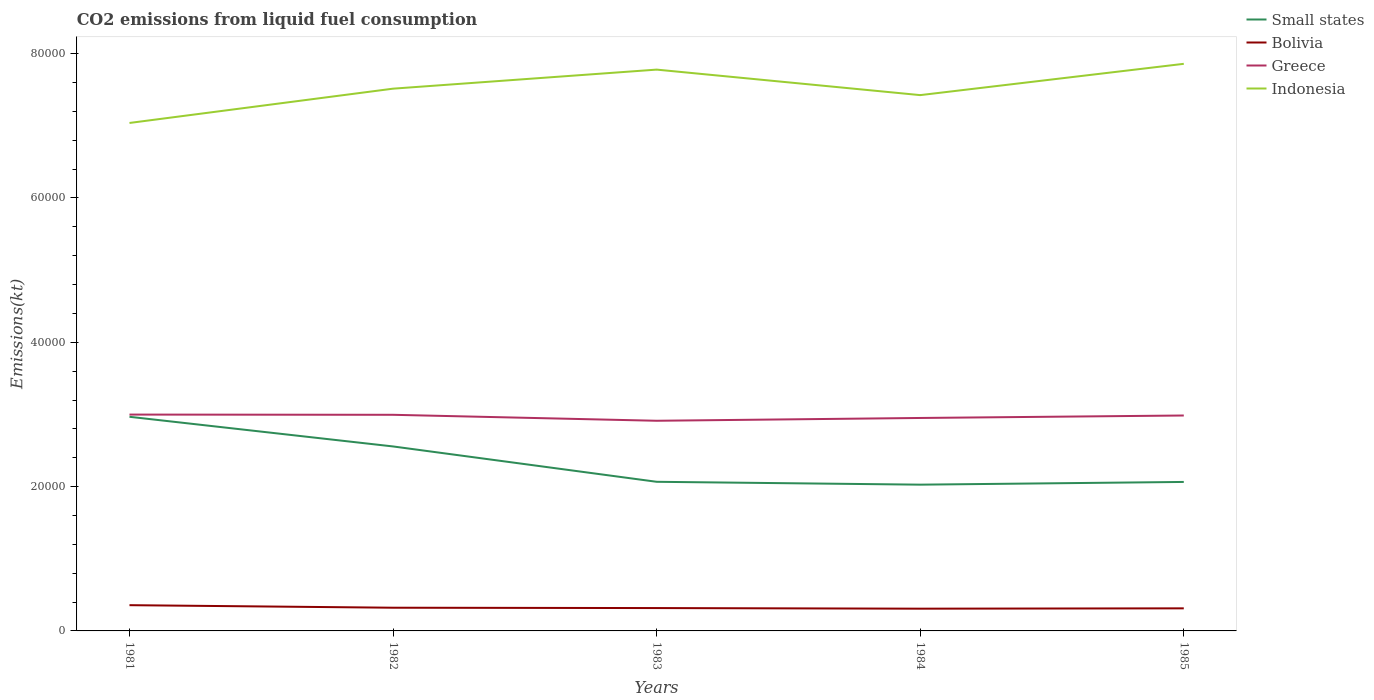Does the line corresponding to Greece intersect with the line corresponding to Bolivia?
Give a very brief answer. No. Across all years, what is the maximum amount of CO2 emitted in Indonesia?
Make the answer very short. 7.04e+04. What is the total amount of CO2 emitted in Greece in the graph?
Provide a succinct answer. 29.34. What is the difference between the highest and the second highest amount of CO2 emitted in Greece?
Offer a very short reply. 858.08. What is the difference between the highest and the lowest amount of CO2 emitted in Bolivia?
Offer a terse response. 1. How many lines are there?
Offer a very short reply. 4. How many years are there in the graph?
Ensure brevity in your answer.  5. What is the title of the graph?
Offer a terse response. CO2 emissions from liquid fuel consumption. Does "Liberia" appear as one of the legend labels in the graph?
Ensure brevity in your answer.  No. What is the label or title of the Y-axis?
Make the answer very short. Emissions(kt). What is the Emissions(kt) in Small states in 1981?
Provide a succinct answer. 2.97e+04. What is the Emissions(kt) of Bolivia in 1981?
Provide a succinct answer. 3567.99. What is the Emissions(kt) in Greece in 1981?
Your response must be concise. 3.00e+04. What is the Emissions(kt) of Indonesia in 1981?
Your response must be concise. 7.04e+04. What is the Emissions(kt) of Small states in 1982?
Your response must be concise. 2.56e+04. What is the Emissions(kt) of Bolivia in 1982?
Make the answer very short. 3215.96. What is the Emissions(kt) in Greece in 1982?
Your answer should be compact. 3.00e+04. What is the Emissions(kt) of Indonesia in 1982?
Ensure brevity in your answer.  7.51e+04. What is the Emissions(kt) of Small states in 1983?
Your answer should be very brief. 2.07e+04. What is the Emissions(kt) of Bolivia in 1983?
Make the answer very short. 3168.29. What is the Emissions(kt) in Greece in 1983?
Offer a terse response. 2.91e+04. What is the Emissions(kt) in Indonesia in 1983?
Ensure brevity in your answer.  7.78e+04. What is the Emissions(kt) of Small states in 1984?
Ensure brevity in your answer.  2.03e+04. What is the Emissions(kt) in Bolivia in 1984?
Offer a very short reply. 3083.95. What is the Emissions(kt) in Greece in 1984?
Ensure brevity in your answer.  2.95e+04. What is the Emissions(kt) in Indonesia in 1984?
Keep it short and to the point. 7.43e+04. What is the Emissions(kt) in Small states in 1985?
Your answer should be very brief. 2.06e+04. What is the Emissions(kt) of Bolivia in 1985?
Your answer should be very brief. 3127.95. What is the Emissions(kt) of Greece in 1985?
Your response must be concise. 2.99e+04. What is the Emissions(kt) of Indonesia in 1985?
Your answer should be very brief. 7.86e+04. Across all years, what is the maximum Emissions(kt) in Small states?
Make the answer very short. 2.97e+04. Across all years, what is the maximum Emissions(kt) in Bolivia?
Ensure brevity in your answer.  3567.99. Across all years, what is the maximum Emissions(kt) in Greece?
Offer a terse response. 3.00e+04. Across all years, what is the maximum Emissions(kt) in Indonesia?
Make the answer very short. 7.86e+04. Across all years, what is the minimum Emissions(kt) in Small states?
Keep it short and to the point. 2.03e+04. Across all years, what is the minimum Emissions(kt) of Bolivia?
Ensure brevity in your answer.  3083.95. Across all years, what is the minimum Emissions(kt) of Greece?
Provide a succinct answer. 2.91e+04. Across all years, what is the minimum Emissions(kt) in Indonesia?
Keep it short and to the point. 7.04e+04. What is the total Emissions(kt) of Small states in the graph?
Provide a short and direct response. 1.17e+05. What is the total Emissions(kt) in Bolivia in the graph?
Offer a very short reply. 1.62e+04. What is the total Emissions(kt) of Greece in the graph?
Offer a very short reply. 1.48e+05. What is the total Emissions(kt) of Indonesia in the graph?
Offer a very short reply. 3.76e+05. What is the difference between the Emissions(kt) in Small states in 1981 and that in 1982?
Provide a short and direct response. 4108.46. What is the difference between the Emissions(kt) in Bolivia in 1981 and that in 1982?
Ensure brevity in your answer.  352.03. What is the difference between the Emissions(kt) of Greece in 1981 and that in 1982?
Provide a short and direct response. 29.34. What is the difference between the Emissions(kt) of Indonesia in 1981 and that in 1982?
Your response must be concise. -4752.43. What is the difference between the Emissions(kt) in Small states in 1981 and that in 1983?
Provide a succinct answer. 9007.46. What is the difference between the Emissions(kt) of Bolivia in 1981 and that in 1983?
Offer a very short reply. 399.7. What is the difference between the Emissions(kt) of Greece in 1981 and that in 1983?
Your answer should be very brief. 858.08. What is the difference between the Emissions(kt) in Indonesia in 1981 and that in 1983?
Offer a very short reply. -7392.67. What is the difference between the Emissions(kt) of Small states in 1981 and that in 1984?
Provide a succinct answer. 9404.67. What is the difference between the Emissions(kt) of Bolivia in 1981 and that in 1984?
Make the answer very short. 484.04. What is the difference between the Emissions(kt) in Greece in 1981 and that in 1984?
Your answer should be compact. 469.38. What is the difference between the Emissions(kt) in Indonesia in 1981 and that in 1984?
Ensure brevity in your answer.  -3857.68. What is the difference between the Emissions(kt) of Small states in 1981 and that in 1985?
Make the answer very short. 9026.93. What is the difference between the Emissions(kt) in Bolivia in 1981 and that in 1985?
Your answer should be very brief. 440.04. What is the difference between the Emissions(kt) of Greece in 1981 and that in 1985?
Offer a very short reply. 128.34. What is the difference between the Emissions(kt) in Indonesia in 1981 and that in 1985?
Keep it short and to the point. -8195.75. What is the difference between the Emissions(kt) of Small states in 1982 and that in 1983?
Your answer should be compact. 4899. What is the difference between the Emissions(kt) in Bolivia in 1982 and that in 1983?
Offer a very short reply. 47.67. What is the difference between the Emissions(kt) of Greece in 1982 and that in 1983?
Keep it short and to the point. 828.74. What is the difference between the Emissions(kt) of Indonesia in 1982 and that in 1983?
Offer a terse response. -2640.24. What is the difference between the Emissions(kt) in Small states in 1982 and that in 1984?
Your response must be concise. 5296.21. What is the difference between the Emissions(kt) of Bolivia in 1982 and that in 1984?
Your answer should be very brief. 132.01. What is the difference between the Emissions(kt) of Greece in 1982 and that in 1984?
Give a very brief answer. 440.04. What is the difference between the Emissions(kt) in Indonesia in 1982 and that in 1984?
Ensure brevity in your answer.  894.75. What is the difference between the Emissions(kt) in Small states in 1982 and that in 1985?
Make the answer very short. 4918.47. What is the difference between the Emissions(kt) of Bolivia in 1982 and that in 1985?
Your answer should be compact. 88.01. What is the difference between the Emissions(kt) in Greece in 1982 and that in 1985?
Give a very brief answer. 99.01. What is the difference between the Emissions(kt) of Indonesia in 1982 and that in 1985?
Your response must be concise. -3443.31. What is the difference between the Emissions(kt) in Small states in 1983 and that in 1984?
Offer a very short reply. 397.22. What is the difference between the Emissions(kt) in Bolivia in 1983 and that in 1984?
Give a very brief answer. 84.34. What is the difference between the Emissions(kt) of Greece in 1983 and that in 1984?
Make the answer very short. -388.7. What is the difference between the Emissions(kt) of Indonesia in 1983 and that in 1984?
Your answer should be compact. 3534.99. What is the difference between the Emissions(kt) in Small states in 1983 and that in 1985?
Offer a terse response. 19.47. What is the difference between the Emissions(kt) in Bolivia in 1983 and that in 1985?
Keep it short and to the point. 40.34. What is the difference between the Emissions(kt) of Greece in 1983 and that in 1985?
Provide a succinct answer. -729.73. What is the difference between the Emissions(kt) in Indonesia in 1983 and that in 1985?
Provide a short and direct response. -803.07. What is the difference between the Emissions(kt) in Small states in 1984 and that in 1985?
Your answer should be very brief. -377.74. What is the difference between the Emissions(kt) in Bolivia in 1984 and that in 1985?
Your response must be concise. -44. What is the difference between the Emissions(kt) in Greece in 1984 and that in 1985?
Offer a very short reply. -341.03. What is the difference between the Emissions(kt) in Indonesia in 1984 and that in 1985?
Your answer should be compact. -4338.06. What is the difference between the Emissions(kt) in Small states in 1981 and the Emissions(kt) in Bolivia in 1982?
Offer a very short reply. 2.65e+04. What is the difference between the Emissions(kt) of Small states in 1981 and the Emissions(kt) of Greece in 1982?
Make the answer very short. -277.69. What is the difference between the Emissions(kt) in Small states in 1981 and the Emissions(kt) in Indonesia in 1982?
Give a very brief answer. -4.55e+04. What is the difference between the Emissions(kt) in Bolivia in 1981 and the Emissions(kt) in Greece in 1982?
Ensure brevity in your answer.  -2.64e+04. What is the difference between the Emissions(kt) of Bolivia in 1981 and the Emissions(kt) of Indonesia in 1982?
Keep it short and to the point. -7.16e+04. What is the difference between the Emissions(kt) of Greece in 1981 and the Emissions(kt) of Indonesia in 1982?
Your answer should be compact. -4.52e+04. What is the difference between the Emissions(kt) in Small states in 1981 and the Emissions(kt) in Bolivia in 1983?
Offer a very short reply. 2.65e+04. What is the difference between the Emissions(kt) in Small states in 1981 and the Emissions(kt) in Greece in 1983?
Offer a terse response. 551.05. What is the difference between the Emissions(kt) in Small states in 1981 and the Emissions(kt) in Indonesia in 1983?
Keep it short and to the point. -4.81e+04. What is the difference between the Emissions(kt) in Bolivia in 1981 and the Emissions(kt) in Greece in 1983?
Offer a very short reply. -2.56e+04. What is the difference between the Emissions(kt) in Bolivia in 1981 and the Emissions(kt) in Indonesia in 1983?
Your response must be concise. -7.42e+04. What is the difference between the Emissions(kt) in Greece in 1981 and the Emissions(kt) in Indonesia in 1983?
Provide a short and direct response. -4.78e+04. What is the difference between the Emissions(kt) in Small states in 1981 and the Emissions(kt) in Bolivia in 1984?
Make the answer very short. 2.66e+04. What is the difference between the Emissions(kt) of Small states in 1981 and the Emissions(kt) of Greece in 1984?
Your answer should be compact. 162.35. What is the difference between the Emissions(kt) of Small states in 1981 and the Emissions(kt) of Indonesia in 1984?
Offer a very short reply. -4.46e+04. What is the difference between the Emissions(kt) in Bolivia in 1981 and the Emissions(kt) in Greece in 1984?
Keep it short and to the point. -2.59e+04. What is the difference between the Emissions(kt) of Bolivia in 1981 and the Emissions(kt) of Indonesia in 1984?
Give a very brief answer. -7.07e+04. What is the difference between the Emissions(kt) in Greece in 1981 and the Emissions(kt) in Indonesia in 1984?
Provide a succinct answer. -4.43e+04. What is the difference between the Emissions(kt) of Small states in 1981 and the Emissions(kt) of Bolivia in 1985?
Keep it short and to the point. 2.65e+04. What is the difference between the Emissions(kt) of Small states in 1981 and the Emissions(kt) of Greece in 1985?
Keep it short and to the point. -178.68. What is the difference between the Emissions(kt) of Small states in 1981 and the Emissions(kt) of Indonesia in 1985?
Ensure brevity in your answer.  -4.89e+04. What is the difference between the Emissions(kt) of Bolivia in 1981 and the Emissions(kt) of Greece in 1985?
Provide a short and direct response. -2.63e+04. What is the difference between the Emissions(kt) of Bolivia in 1981 and the Emissions(kt) of Indonesia in 1985?
Your answer should be very brief. -7.50e+04. What is the difference between the Emissions(kt) of Greece in 1981 and the Emissions(kt) of Indonesia in 1985?
Keep it short and to the point. -4.86e+04. What is the difference between the Emissions(kt) in Small states in 1982 and the Emissions(kt) in Bolivia in 1983?
Your response must be concise. 2.24e+04. What is the difference between the Emissions(kt) of Small states in 1982 and the Emissions(kt) of Greece in 1983?
Keep it short and to the point. -3557.4. What is the difference between the Emissions(kt) in Small states in 1982 and the Emissions(kt) in Indonesia in 1983?
Your answer should be compact. -5.22e+04. What is the difference between the Emissions(kt) in Bolivia in 1982 and the Emissions(kt) in Greece in 1983?
Make the answer very short. -2.59e+04. What is the difference between the Emissions(kt) of Bolivia in 1982 and the Emissions(kt) of Indonesia in 1983?
Keep it short and to the point. -7.46e+04. What is the difference between the Emissions(kt) in Greece in 1982 and the Emissions(kt) in Indonesia in 1983?
Provide a short and direct response. -4.78e+04. What is the difference between the Emissions(kt) of Small states in 1982 and the Emissions(kt) of Bolivia in 1984?
Your answer should be very brief. 2.25e+04. What is the difference between the Emissions(kt) in Small states in 1982 and the Emissions(kt) in Greece in 1984?
Offer a very short reply. -3946.11. What is the difference between the Emissions(kt) of Small states in 1982 and the Emissions(kt) of Indonesia in 1984?
Give a very brief answer. -4.87e+04. What is the difference between the Emissions(kt) in Bolivia in 1982 and the Emissions(kt) in Greece in 1984?
Keep it short and to the point. -2.63e+04. What is the difference between the Emissions(kt) of Bolivia in 1982 and the Emissions(kt) of Indonesia in 1984?
Give a very brief answer. -7.10e+04. What is the difference between the Emissions(kt) of Greece in 1982 and the Emissions(kt) of Indonesia in 1984?
Keep it short and to the point. -4.43e+04. What is the difference between the Emissions(kt) of Small states in 1982 and the Emissions(kt) of Bolivia in 1985?
Offer a very short reply. 2.24e+04. What is the difference between the Emissions(kt) of Small states in 1982 and the Emissions(kt) of Greece in 1985?
Offer a very short reply. -4287.14. What is the difference between the Emissions(kt) in Small states in 1982 and the Emissions(kt) in Indonesia in 1985?
Provide a succinct answer. -5.30e+04. What is the difference between the Emissions(kt) of Bolivia in 1982 and the Emissions(kt) of Greece in 1985?
Make the answer very short. -2.66e+04. What is the difference between the Emissions(kt) in Bolivia in 1982 and the Emissions(kt) in Indonesia in 1985?
Your answer should be very brief. -7.54e+04. What is the difference between the Emissions(kt) of Greece in 1982 and the Emissions(kt) of Indonesia in 1985?
Make the answer very short. -4.86e+04. What is the difference between the Emissions(kt) in Small states in 1983 and the Emissions(kt) in Bolivia in 1984?
Offer a terse response. 1.76e+04. What is the difference between the Emissions(kt) in Small states in 1983 and the Emissions(kt) in Greece in 1984?
Your answer should be compact. -8845.1. What is the difference between the Emissions(kt) in Small states in 1983 and the Emissions(kt) in Indonesia in 1984?
Your answer should be very brief. -5.36e+04. What is the difference between the Emissions(kt) of Bolivia in 1983 and the Emissions(kt) of Greece in 1984?
Provide a succinct answer. -2.63e+04. What is the difference between the Emissions(kt) in Bolivia in 1983 and the Emissions(kt) in Indonesia in 1984?
Make the answer very short. -7.11e+04. What is the difference between the Emissions(kt) in Greece in 1983 and the Emissions(kt) in Indonesia in 1984?
Give a very brief answer. -4.51e+04. What is the difference between the Emissions(kt) of Small states in 1983 and the Emissions(kt) of Bolivia in 1985?
Keep it short and to the point. 1.75e+04. What is the difference between the Emissions(kt) of Small states in 1983 and the Emissions(kt) of Greece in 1985?
Provide a succinct answer. -9186.13. What is the difference between the Emissions(kt) in Small states in 1983 and the Emissions(kt) in Indonesia in 1985?
Keep it short and to the point. -5.79e+04. What is the difference between the Emissions(kt) of Bolivia in 1983 and the Emissions(kt) of Greece in 1985?
Keep it short and to the point. -2.67e+04. What is the difference between the Emissions(kt) of Bolivia in 1983 and the Emissions(kt) of Indonesia in 1985?
Ensure brevity in your answer.  -7.54e+04. What is the difference between the Emissions(kt) in Greece in 1983 and the Emissions(kt) in Indonesia in 1985?
Offer a very short reply. -4.95e+04. What is the difference between the Emissions(kt) of Small states in 1984 and the Emissions(kt) of Bolivia in 1985?
Provide a short and direct response. 1.71e+04. What is the difference between the Emissions(kt) in Small states in 1984 and the Emissions(kt) in Greece in 1985?
Offer a very short reply. -9583.35. What is the difference between the Emissions(kt) of Small states in 1984 and the Emissions(kt) of Indonesia in 1985?
Your answer should be very brief. -5.83e+04. What is the difference between the Emissions(kt) in Bolivia in 1984 and the Emissions(kt) in Greece in 1985?
Provide a short and direct response. -2.68e+04. What is the difference between the Emissions(kt) in Bolivia in 1984 and the Emissions(kt) in Indonesia in 1985?
Keep it short and to the point. -7.55e+04. What is the difference between the Emissions(kt) of Greece in 1984 and the Emissions(kt) of Indonesia in 1985?
Your answer should be very brief. -4.91e+04. What is the average Emissions(kt) in Small states per year?
Offer a terse response. 2.34e+04. What is the average Emissions(kt) in Bolivia per year?
Ensure brevity in your answer.  3232.83. What is the average Emissions(kt) of Greece per year?
Ensure brevity in your answer.  2.97e+04. What is the average Emissions(kt) in Indonesia per year?
Your answer should be compact. 7.52e+04. In the year 1981, what is the difference between the Emissions(kt) in Small states and Emissions(kt) in Bolivia?
Keep it short and to the point. 2.61e+04. In the year 1981, what is the difference between the Emissions(kt) in Small states and Emissions(kt) in Greece?
Your response must be concise. -307.02. In the year 1981, what is the difference between the Emissions(kt) of Small states and Emissions(kt) of Indonesia?
Keep it short and to the point. -4.07e+04. In the year 1981, what is the difference between the Emissions(kt) of Bolivia and Emissions(kt) of Greece?
Give a very brief answer. -2.64e+04. In the year 1981, what is the difference between the Emissions(kt) in Bolivia and Emissions(kt) in Indonesia?
Provide a short and direct response. -6.68e+04. In the year 1981, what is the difference between the Emissions(kt) in Greece and Emissions(kt) in Indonesia?
Provide a succinct answer. -4.04e+04. In the year 1982, what is the difference between the Emissions(kt) of Small states and Emissions(kt) of Bolivia?
Ensure brevity in your answer.  2.23e+04. In the year 1982, what is the difference between the Emissions(kt) of Small states and Emissions(kt) of Greece?
Give a very brief answer. -4386.15. In the year 1982, what is the difference between the Emissions(kt) in Small states and Emissions(kt) in Indonesia?
Your response must be concise. -4.96e+04. In the year 1982, what is the difference between the Emissions(kt) of Bolivia and Emissions(kt) of Greece?
Your answer should be very brief. -2.67e+04. In the year 1982, what is the difference between the Emissions(kt) of Bolivia and Emissions(kt) of Indonesia?
Provide a succinct answer. -7.19e+04. In the year 1982, what is the difference between the Emissions(kt) of Greece and Emissions(kt) of Indonesia?
Provide a short and direct response. -4.52e+04. In the year 1983, what is the difference between the Emissions(kt) in Small states and Emissions(kt) in Bolivia?
Offer a very short reply. 1.75e+04. In the year 1983, what is the difference between the Emissions(kt) of Small states and Emissions(kt) of Greece?
Your response must be concise. -8456.4. In the year 1983, what is the difference between the Emissions(kt) in Small states and Emissions(kt) in Indonesia?
Offer a terse response. -5.71e+04. In the year 1983, what is the difference between the Emissions(kt) in Bolivia and Emissions(kt) in Greece?
Provide a succinct answer. -2.60e+04. In the year 1983, what is the difference between the Emissions(kt) in Bolivia and Emissions(kt) in Indonesia?
Keep it short and to the point. -7.46e+04. In the year 1983, what is the difference between the Emissions(kt) in Greece and Emissions(kt) in Indonesia?
Make the answer very short. -4.87e+04. In the year 1984, what is the difference between the Emissions(kt) of Small states and Emissions(kt) of Bolivia?
Ensure brevity in your answer.  1.72e+04. In the year 1984, what is the difference between the Emissions(kt) in Small states and Emissions(kt) in Greece?
Ensure brevity in your answer.  -9242.32. In the year 1984, what is the difference between the Emissions(kt) of Small states and Emissions(kt) of Indonesia?
Provide a short and direct response. -5.40e+04. In the year 1984, what is the difference between the Emissions(kt) of Bolivia and Emissions(kt) of Greece?
Your answer should be compact. -2.64e+04. In the year 1984, what is the difference between the Emissions(kt) in Bolivia and Emissions(kt) in Indonesia?
Offer a very short reply. -7.12e+04. In the year 1984, what is the difference between the Emissions(kt) of Greece and Emissions(kt) of Indonesia?
Offer a very short reply. -4.47e+04. In the year 1985, what is the difference between the Emissions(kt) of Small states and Emissions(kt) of Bolivia?
Your answer should be very brief. 1.75e+04. In the year 1985, what is the difference between the Emissions(kt) of Small states and Emissions(kt) of Greece?
Provide a succinct answer. -9205.61. In the year 1985, what is the difference between the Emissions(kt) in Small states and Emissions(kt) in Indonesia?
Your response must be concise. -5.79e+04. In the year 1985, what is the difference between the Emissions(kt) in Bolivia and Emissions(kt) in Greece?
Provide a succinct answer. -2.67e+04. In the year 1985, what is the difference between the Emissions(kt) of Bolivia and Emissions(kt) of Indonesia?
Provide a succinct answer. -7.55e+04. In the year 1985, what is the difference between the Emissions(kt) of Greece and Emissions(kt) of Indonesia?
Your answer should be compact. -4.87e+04. What is the ratio of the Emissions(kt) of Small states in 1981 to that in 1982?
Offer a very short reply. 1.16. What is the ratio of the Emissions(kt) in Bolivia in 1981 to that in 1982?
Your response must be concise. 1.11. What is the ratio of the Emissions(kt) of Greece in 1981 to that in 1982?
Offer a very short reply. 1. What is the ratio of the Emissions(kt) of Indonesia in 1981 to that in 1982?
Make the answer very short. 0.94. What is the ratio of the Emissions(kt) of Small states in 1981 to that in 1983?
Your answer should be very brief. 1.44. What is the ratio of the Emissions(kt) of Bolivia in 1981 to that in 1983?
Provide a short and direct response. 1.13. What is the ratio of the Emissions(kt) of Greece in 1981 to that in 1983?
Offer a very short reply. 1.03. What is the ratio of the Emissions(kt) in Indonesia in 1981 to that in 1983?
Keep it short and to the point. 0.91. What is the ratio of the Emissions(kt) in Small states in 1981 to that in 1984?
Provide a succinct answer. 1.46. What is the ratio of the Emissions(kt) in Bolivia in 1981 to that in 1984?
Provide a short and direct response. 1.16. What is the ratio of the Emissions(kt) in Greece in 1981 to that in 1984?
Provide a succinct answer. 1.02. What is the ratio of the Emissions(kt) in Indonesia in 1981 to that in 1984?
Provide a short and direct response. 0.95. What is the ratio of the Emissions(kt) in Small states in 1981 to that in 1985?
Your answer should be compact. 1.44. What is the ratio of the Emissions(kt) of Bolivia in 1981 to that in 1985?
Keep it short and to the point. 1.14. What is the ratio of the Emissions(kt) of Indonesia in 1981 to that in 1985?
Provide a succinct answer. 0.9. What is the ratio of the Emissions(kt) of Small states in 1982 to that in 1983?
Your answer should be very brief. 1.24. What is the ratio of the Emissions(kt) in Bolivia in 1982 to that in 1983?
Offer a very short reply. 1.01. What is the ratio of the Emissions(kt) of Greece in 1982 to that in 1983?
Ensure brevity in your answer.  1.03. What is the ratio of the Emissions(kt) of Indonesia in 1982 to that in 1983?
Keep it short and to the point. 0.97. What is the ratio of the Emissions(kt) of Small states in 1982 to that in 1984?
Provide a succinct answer. 1.26. What is the ratio of the Emissions(kt) in Bolivia in 1982 to that in 1984?
Your answer should be very brief. 1.04. What is the ratio of the Emissions(kt) in Greece in 1982 to that in 1984?
Make the answer very short. 1.01. What is the ratio of the Emissions(kt) in Indonesia in 1982 to that in 1984?
Your answer should be very brief. 1.01. What is the ratio of the Emissions(kt) of Small states in 1982 to that in 1985?
Give a very brief answer. 1.24. What is the ratio of the Emissions(kt) in Bolivia in 1982 to that in 1985?
Your response must be concise. 1.03. What is the ratio of the Emissions(kt) in Indonesia in 1982 to that in 1985?
Keep it short and to the point. 0.96. What is the ratio of the Emissions(kt) in Small states in 1983 to that in 1984?
Provide a succinct answer. 1.02. What is the ratio of the Emissions(kt) in Bolivia in 1983 to that in 1984?
Provide a short and direct response. 1.03. What is the ratio of the Emissions(kt) of Greece in 1983 to that in 1984?
Your answer should be compact. 0.99. What is the ratio of the Emissions(kt) of Indonesia in 1983 to that in 1984?
Your answer should be very brief. 1.05. What is the ratio of the Emissions(kt) of Bolivia in 1983 to that in 1985?
Offer a terse response. 1.01. What is the ratio of the Emissions(kt) of Greece in 1983 to that in 1985?
Make the answer very short. 0.98. What is the ratio of the Emissions(kt) in Indonesia in 1983 to that in 1985?
Offer a very short reply. 0.99. What is the ratio of the Emissions(kt) in Small states in 1984 to that in 1985?
Offer a terse response. 0.98. What is the ratio of the Emissions(kt) of Bolivia in 1984 to that in 1985?
Give a very brief answer. 0.99. What is the ratio of the Emissions(kt) of Indonesia in 1984 to that in 1985?
Keep it short and to the point. 0.94. What is the difference between the highest and the second highest Emissions(kt) of Small states?
Give a very brief answer. 4108.46. What is the difference between the highest and the second highest Emissions(kt) in Bolivia?
Provide a short and direct response. 352.03. What is the difference between the highest and the second highest Emissions(kt) of Greece?
Your answer should be very brief. 29.34. What is the difference between the highest and the second highest Emissions(kt) in Indonesia?
Give a very brief answer. 803.07. What is the difference between the highest and the lowest Emissions(kt) in Small states?
Keep it short and to the point. 9404.67. What is the difference between the highest and the lowest Emissions(kt) in Bolivia?
Offer a terse response. 484.04. What is the difference between the highest and the lowest Emissions(kt) of Greece?
Provide a succinct answer. 858.08. What is the difference between the highest and the lowest Emissions(kt) of Indonesia?
Keep it short and to the point. 8195.75. 